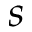Convert formula to latex. <formula><loc_0><loc_0><loc_500><loc_500>s</formula> 